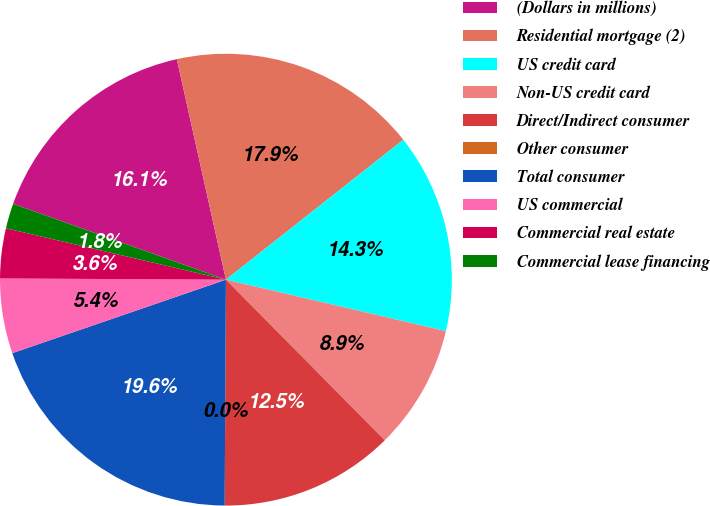<chart> <loc_0><loc_0><loc_500><loc_500><pie_chart><fcel>(Dollars in millions)<fcel>Residential mortgage (2)<fcel>US credit card<fcel>Non-US credit card<fcel>Direct/Indirect consumer<fcel>Other consumer<fcel>Total consumer<fcel>US commercial<fcel>Commercial real estate<fcel>Commercial lease financing<nl><fcel>16.07%<fcel>17.86%<fcel>14.29%<fcel>8.93%<fcel>12.5%<fcel>0.0%<fcel>19.64%<fcel>5.36%<fcel>3.57%<fcel>1.79%<nl></chart> 